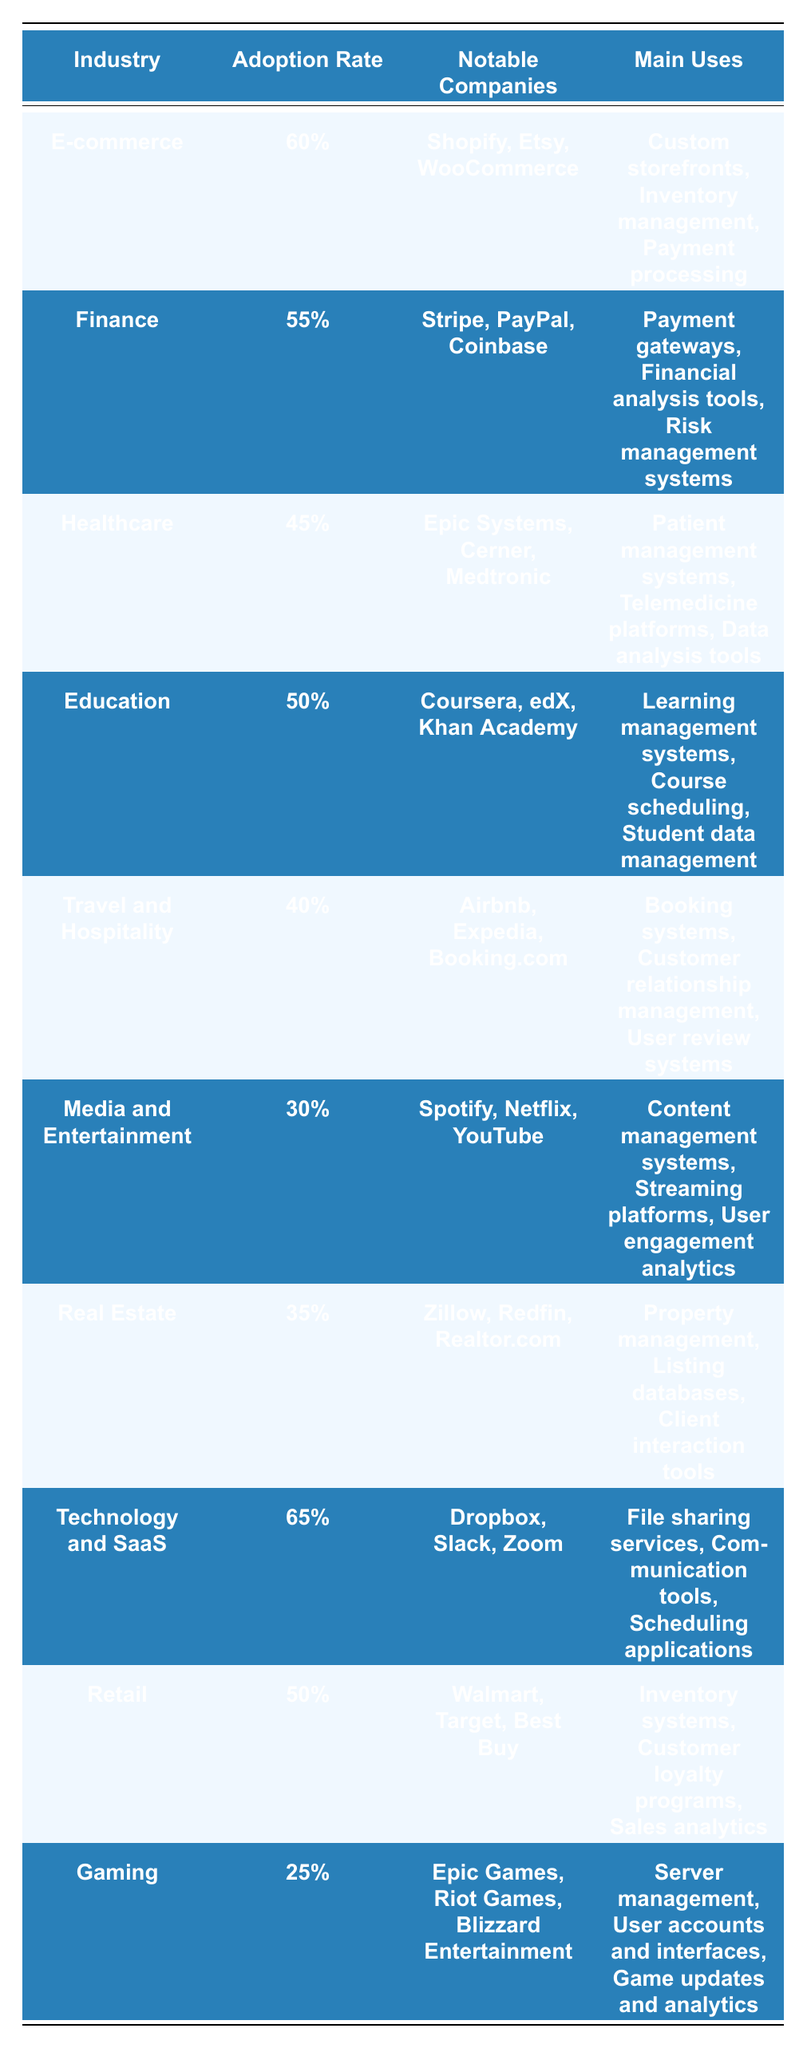What is the adoption rate of Django in the Technology and SaaS industry? By looking at the table, the adoption rate for the Technology and SaaS industry is listed directly alongside the industry name. It shows an adoption rate of 65%.
Answer: 65% Which industry has the highest adoption rate of Django? The table shows the adoption rates for various industries. The highest rate is 65% for the Technology and SaaS industry.
Answer: Technology and SaaS How many notable companies are listed under the Finance industry? In the row for the Finance industry, there are three notable companies mentioned: Stripe, PayPal, and Coinbase.
Answer: 3 What is the adoption rate difference between the E-commerce and Retail industries? The E-commerce industry has an adoption rate of 60%, while the Retail industry has an adoption rate of 50%. The difference is calculated as 60% - 50% = 10%.
Answer: 10% Which industries have an adoption rate lower than 40%? By examining the table, the only industry with an adoption rate lower than 40% is Gaming, which has an adoption rate of 25%.
Answer: Gaming Is Django more widely adopted in the Healthcare industry than in the Travel and Hospitality industry? The table lists the adoption rate for Healthcare as 45% and for Travel and Hospitality as 40%. Since 45% is greater than 40%, Django is more widely adopted in Healthcare.
Answer: Yes What are the main uses of Django in the E-commerce industry? The table specifies that the main uses of Django in the E-commerce industry include custom storefronts, inventory management, and payment processing.
Answer: Custom storefronts, inventory management, payment processing Considering the healthcare and education sectors, which sector has a higher number of notable companies? The healthcare sector has three notable companies (Epic Systems, Cerner, Medtronic) and the education sector also has three notable companies (Coursera, edX, Khan Academy). As both have the same number, we can conclude that neither has a higher count.
Answer: Neither What is the average adoption rate of Django among all the industries listed? To calculate the average, sum the adoption rates: 60% + 55% + 45% + 50% + 40% + 30% + 35% + 65% + 50% + 25% = 455%. Divided by the number of industries, which is 10, gives an average of 45.5%.
Answer: 45.5% Which industry has a similar adoption rate to both the Real Estate and Media and Entertainment industries? The adoption rate for Real Estate is 35% and for Media and Entertainment is 30%. The Education industry has an adoption rate of 50%, which is far higher, while the Finance industry has 55%, so no industry shares a similar rate.
Answer: No industry 